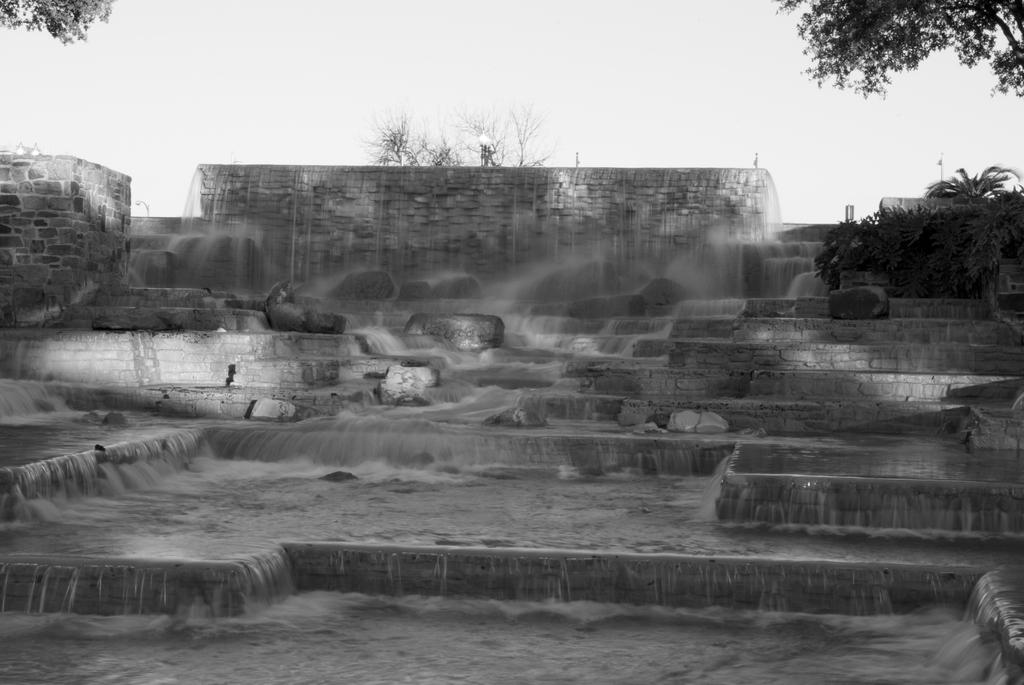What type of water feature is present in the image? There is a fountain-like waterfall in the image. What can be seen on the waterfall? There are stones on the waterfall. What type of vegetation is near the waterfall? There are plants and trees near the waterfall. Where is the quill used for writing in the image? There is no quill present in the image. What type of lamp is illuminating the waterfall in the image? There is no lamp present in the image; the waterfall is not illuminated. 